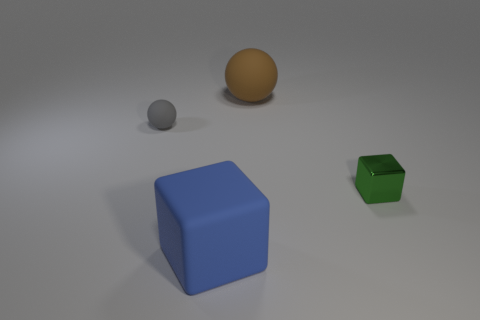Subtract 1 spheres. How many spheres are left? 1 Add 3 small rubber cylinders. How many objects exist? 7 Add 3 rubber things. How many rubber things are left? 6 Add 1 small green metallic cubes. How many small green metallic cubes exist? 2 Subtract 0 green balls. How many objects are left? 4 Subtract all purple spheres. Subtract all red cylinders. How many spheres are left? 2 Subtract all brown blocks. How many yellow balls are left? 0 Subtract all purple shiny spheres. Subtract all tiny gray spheres. How many objects are left? 3 